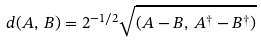Convert formula to latex. <formula><loc_0><loc_0><loc_500><loc_500>d ( A , \, B ) = 2 ^ { - 1 / 2 } \sqrt { ( A - B , \, A ^ { \dagger } - B ^ { \dagger } ) }</formula> 